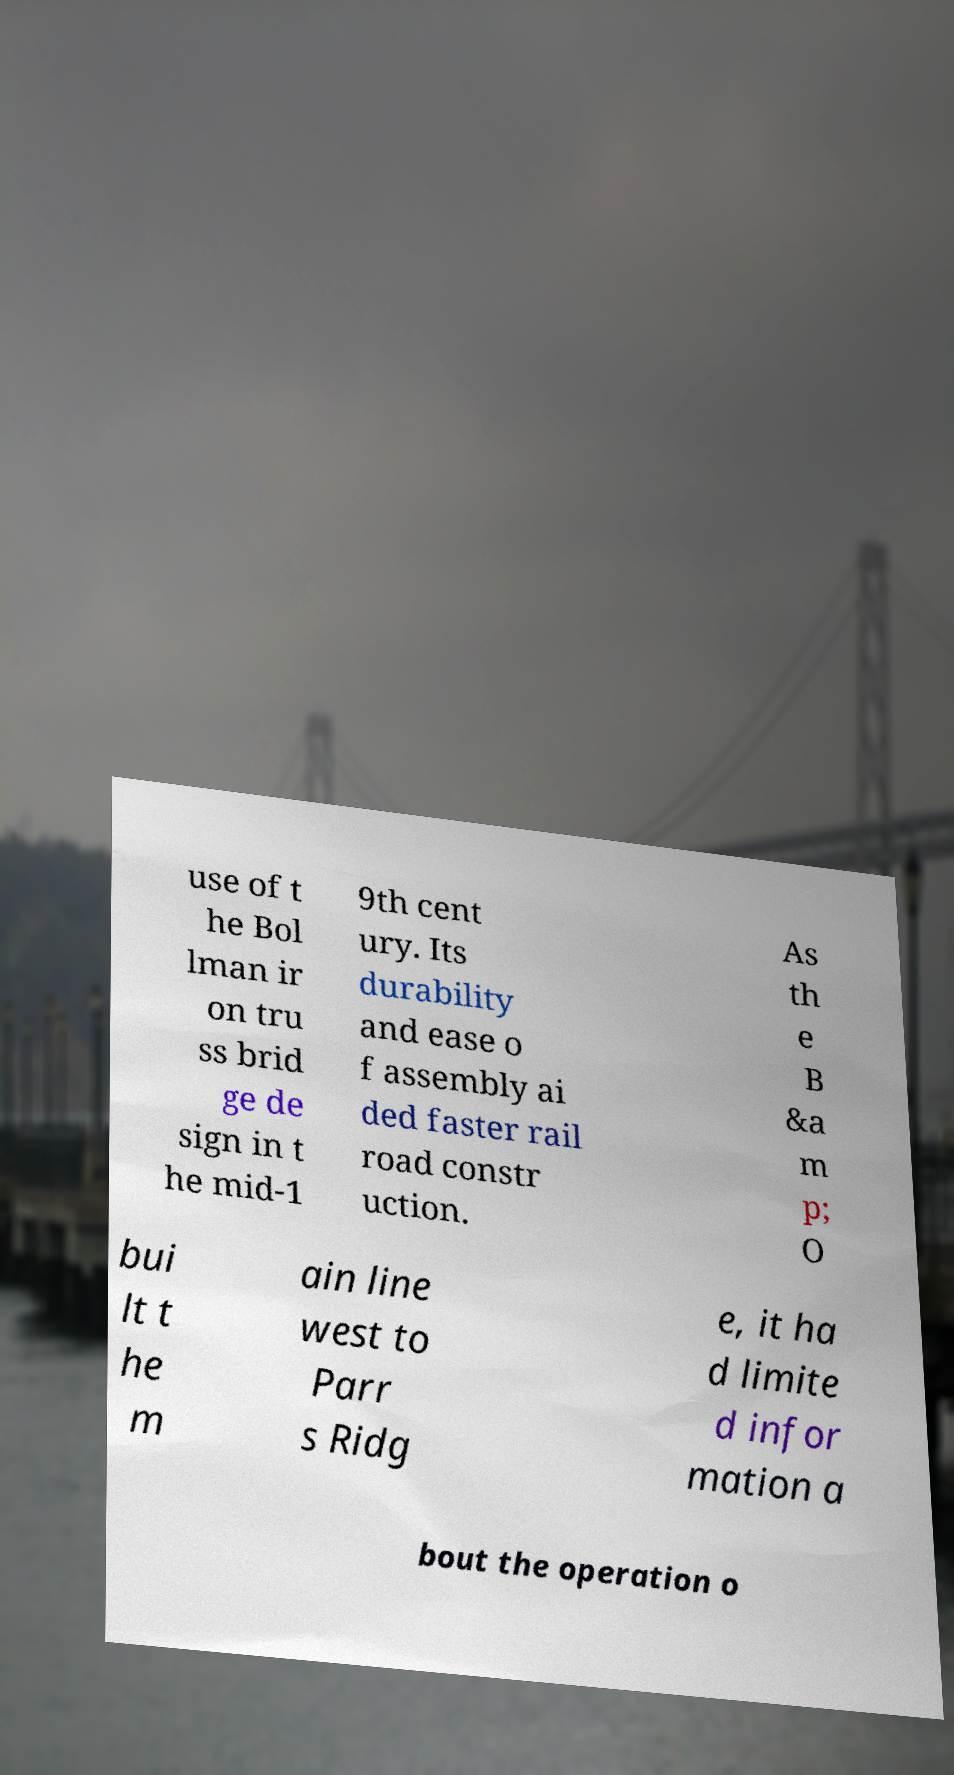Could you assist in decoding the text presented in this image and type it out clearly? use of t he Bol lman ir on tru ss brid ge de sign in t he mid-1 9th cent ury. Its durability and ease o f assembly ai ded faster rail road constr uction. As th e B &a m p; O bui lt t he m ain line west to Parr s Ridg e, it ha d limite d infor mation a bout the operation o 